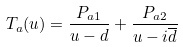<formula> <loc_0><loc_0><loc_500><loc_500>T _ { a } ( u ) = \frac { P _ { a 1 } } { u - d } + \frac { P _ { a 2 } } { u - i { \overline { d } } }</formula> 